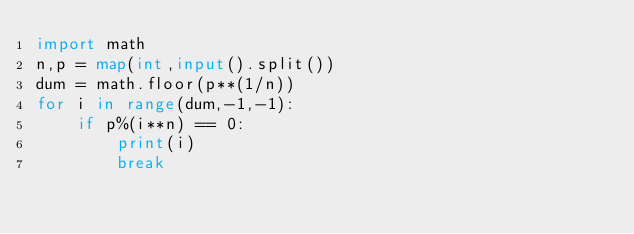<code> <loc_0><loc_0><loc_500><loc_500><_Python_>import math
n,p = map(int,input().split())
dum = math.floor(p**(1/n))
for i in range(dum,-1,-1):
    if p%(i**n) == 0:
        print(i)
        break</code> 